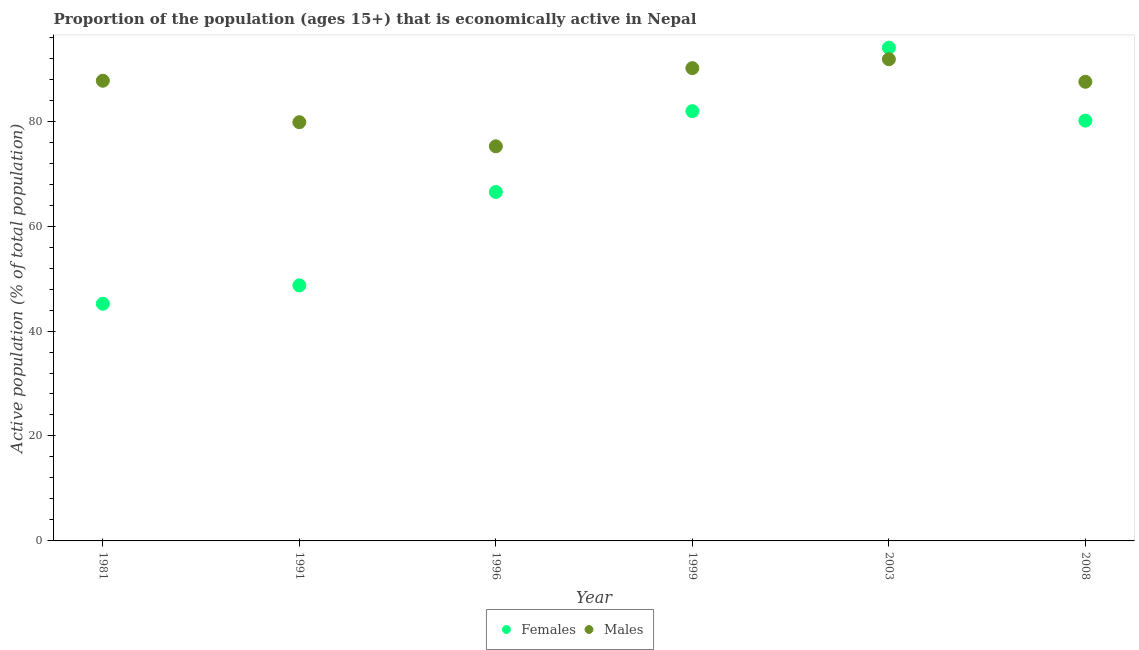Is the number of dotlines equal to the number of legend labels?
Keep it short and to the point. Yes. What is the percentage of economically active female population in 1991?
Offer a very short reply. 48.7. Across all years, what is the maximum percentage of economically active female population?
Provide a short and direct response. 94. Across all years, what is the minimum percentage of economically active male population?
Your answer should be compact. 75.2. In which year was the percentage of economically active female population maximum?
Provide a short and direct response. 2003. What is the total percentage of economically active male population in the graph?
Your answer should be compact. 512.1. What is the difference between the percentage of economically active female population in 1991 and that in 2003?
Give a very brief answer. -45.3. What is the difference between the percentage of economically active female population in 2003 and the percentage of economically active male population in 1996?
Offer a very short reply. 18.8. What is the average percentage of economically active male population per year?
Give a very brief answer. 85.35. In the year 1981, what is the difference between the percentage of economically active male population and percentage of economically active female population?
Offer a very short reply. 42.5. In how many years, is the percentage of economically active male population greater than 76 %?
Keep it short and to the point. 5. What is the ratio of the percentage of economically active male population in 1981 to that in 2003?
Provide a succinct answer. 0.96. Is the percentage of economically active male population in 1981 less than that in 2003?
Offer a terse response. Yes. Is the difference between the percentage of economically active male population in 1981 and 2003 greater than the difference between the percentage of economically active female population in 1981 and 2003?
Provide a short and direct response. Yes. What is the difference between the highest and the second highest percentage of economically active female population?
Your answer should be very brief. 12.1. What is the difference between the highest and the lowest percentage of economically active male population?
Keep it short and to the point. 16.6. In how many years, is the percentage of economically active female population greater than the average percentage of economically active female population taken over all years?
Your answer should be very brief. 3. Is the sum of the percentage of economically active male population in 1996 and 2008 greater than the maximum percentage of economically active female population across all years?
Provide a succinct answer. Yes. Does the percentage of economically active female population monotonically increase over the years?
Your answer should be very brief. No. Is the percentage of economically active male population strictly less than the percentage of economically active female population over the years?
Ensure brevity in your answer.  No. How many years are there in the graph?
Make the answer very short. 6. Where does the legend appear in the graph?
Your answer should be compact. Bottom center. How many legend labels are there?
Give a very brief answer. 2. What is the title of the graph?
Your answer should be compact. Proportion of the population (ages 15+) that is economically active in Nepal. What is the label or title of the Y-axis?
Keep it short and to the point. Active population (% of total population). What is the Active population (% of total population) in Females in 1981?
Offer a very short reply. 45.2. What is the Active population (% of total population) in Males in 1981?
Your answer should be very brief. 87.7. What is the Active population (% of total population) in Females in 1991?
Keep it short and to the point. 48.7. What is the Active population (% of total population) of Males in 1991?
Give a very brief answer. 79.8. What is the Active population (% of total population) of Females in 1996?
Offer a very short reply. 66.5. What is the Active population (% of total population) in Males in 1996?
Provide a short and direct response. 75.2. What is the Active population (% of total population) in Females in 1999?
Offer a terse response. 81.9. What is the Active population (% of total population) in Males in 1999?
Make the answer very short. 90.1. What is the Active population (% of total population) in Females in 2003?
Your answer should be compact. 94. What is the Active population (% of total population) of Males in 2003?
Provide a succinct answer. 91.8. What is the Active population (% of total population) of Females in 2008?
Ensure brevity in your answer.  80.1. What is the Active population (% of total population) of Males in 2008?
Give a very brief answer. 87.5. Across all years, what is the maximum Active population (% of total population) of Females?
Provide a short and direct response. 94. Across all years, what is the maximum Active population (% of total population) of Males?
Offer a very short reply. 91.8. Across all years, what is the minimum Active population (% of total population) in Females?
Give a very brief answer. 45.2. Across all years, what is the minimum Active population (% of total population) in Males?
Offer a terse response. 75.2. What is the total Active population (% of total population) of Females in the graph?
Your answer should be very brief. 416.4. What is the total Active population (% of total population) of Males in the graph?
Make the answer very short. 512.1. What is the difference between the Active population (% of total population) in Females in 1981 and that in 1991?
Give a very brief answer. -3.5. What is the difference between the Active population (% of total population) in Males in 1981 and that in 1991?
Your answer should be very brief. 7.9. What is the difference between the Active population (% of total population) in Females in 1981 and that in 1996?
Provide a succinct answer. -21.3. What is the difference between the Active population (% of total population) of Females in 1981 and that in 1999?
Your answer should be very brief. -36.7. What is the difference between the Active population (% of total population) of Males in 1981 and that in 1999?
Provide a short and direct response. -2.4. What is the difference between the Active population (% of total population) in Females in 1981 and that in 2003?
Offer a terse response. -48.8. What is the difference between the Active population (% of total population) in Males in 1981 and that in 2003?
Ensure brevity in your answer.  -4.1. What is the difference between the Active population (% of total population) of Females in 1981 and that in 2008?
Provide a short and direct response. -34.9. What is the difference between the Active population (% of total population) in Males in 1981 and that in 2008?
Your answer should be compact. 0.2. What is the difference between the Active population (% of total population) of Females in 1991 and that in 1996?
Your response must be concise. -17.8. What is the difference between the Active population (% of total population) in Females in 1991 and that in 1999?
Your answer should be compact. -33.2. What is the difference between the Active population (% of total population) in Females in 1991 and that in 2003?
Your answer should be compact. -45.3. What is the difference between the Active population (% of total population) in Females in 1991 and that in 2008?
Give a very brief answer. -31.4. What is the difference between the Active population (% of total population) of Females in 1996 and that in 1999?
Give a very brief answer. -15.4. What is the difference between the Active population (% of total population) in Males in 1996 and that in 1999?
Offer a terse response. -14.9. What is the difference between the Active population (% of total population) of Females in 1996 and that in 2003?
Your answer should be very brief. -27.5. What is the difference between the Active population (% of total population) of Males in 1996 and that in 2003?
Your response must be concise. -16.6. What is the difference between the Active population (% of total population) in Males in 1996 and that in 2008?
Provide a succinct answer. -12.3. What is the difference between the Active population (% of total population) of Females in 1999 and that in 2003?
Your answer should be compact. -12.1. What is the difference between the Active population (% of total population) of Females in 2003 and that in 2008?
Your answer should be compact. 13.9. What is the difference between the Active population (% of total population) of Males in 2003 and that in 2008?
Provide a succinct answer. 4.3. What is the difference between the Active population (% of total population) in Females in 1981 and the Active population (% of total population) in Males in 1991?
Ensure brevity in your answer.  -34.6. What is the difference between the Active population (% of total population) in Females in 1981 and the Active population (% of total population) in Males in 1999?
Ensure brevity in your answer.  -44.9. What is the difference between the Active population (% of total population) in Females in 1981 and the Active population (% of total population) in Males in 2003?
Provide a succinct answer. -46.6. What is the difference between the Active population (% of total population) of Females in 1981 and the Active population (% of total population) of Males in 2008?
Ensure brevity in your answer.  -42.3. What is the difference between the Active population (% of total population) in Females in 1991 and the Active population (% of total population) in Males in 1996?
Offer a very short reply. -26.5. What is the difference between the Active population (% of total population) in Females in 1991 and the Active population (% of total population) in Males in 1999?
Your response must be concise. -41.4. What is the difference between the Active population (% of total population) in Females in 1991 and the Active population (% of total population) in Males in 2003?
Provide a short and direct response. -43.1. What is the difference between the Active population (% of total population) in Females in 1991 and the Active population (% of total population) in Males in 2008?
Offer a terse response. -38.8. What is the difference between the Active population (% of total population) of Females in 1996 and the Active population (% of total population) of Males in 1999?
Provide a succinct answer. -23.6. What is the difference between the Active population (% of total population) in Females in 1996 and the Active population (% of total population) in Males in 2003?
Your answer should be very brief. -25.3. What is the difference between the Active population (% of total population) in Females in 1996 and the Active population (% of total population) in Males in 2008?
Provide a succinct answer. -21. What is the difference between the Active population (% of total population) in Females in 1999 and the Active population (% of total population) in Males in 2008?
Give a very brief answer. -5.6. What is the average Active population (% of total population) of Females per year?
Make the answer very short. 69.4. What is the average Active population (% of total population) in Males per year?
Keep it short and to the point. 85.35. In the year 1981, what is the difference between the Active population (% of total population) of Females and Active population (% of total population) of Males?
Provide a short and direct response. -42.5. In the year 1991, what is the difference between the Active population (% of total population) in Females and Active population (% of total population) in Males?
Offer a very short reply. -31.1. In the year 1996, what is the difference between the Active population (% of total population) of Females and Active population (% of total population) of Males?
Keep it short and to the point. -8.7. In the year 1999, what is the difference between the Active population (% of total population) in Females and Active population (% of total population) in Males?
Ensure brevity in your answer.  -8.2. In the year 2003, what is the difference between the Active population (% of total population) of Females and Active population (% of total population) of Males?
Provide a succinct answer. 2.2. What is the ratio of the Active population (% of total population) in Females in 1981 to that in 1991?
Your response must be concise. 0.93. What is the ratio of the Active population (% of total population) of Males in 1981 to that in 1991?
Provide a succinct answer. 1.1. What is the ratio of the Active population (% of total population) in Females in 1981 to that in 1996?
Ensure brevity in your answer.  0.68. What is the ratio of the Active population (% of total population) of Males in 1981 to that in 1996?
Offer a very short reply. 1.17. What is the ratio of the Active population (% of total population) in Females in 1981 to that in 1999?
Provide a short and direct response. 0.55. What is the ratio of the Active population (% of total population) of Males in 1981 to that in 1999?
Keep it short and to the point. 0.97. What is the ratio of the Active population (% of total population) in Females in 1981 to that in 2003?
Provide a short and direct response. 0.48. What is the ratio of the Active population (% of total population) in Males in 1981 to that in 2003?
Keep it short and to the point. 0.96. What is the ratio of the Active population (% of total population) of Females in 1981 to that in 2008?
Offer a terse response. 0.56. What is the ratio of the Active population (% of total population) in Females in 1991 to that in 1996?
Make the answer very short. 0.73. What is the ratio of the Active population (% of total population) of Males in 1991 to that in 1996?
Provide a succinct answer. 1.06. What is the ratio of the Active population (% of total population) of Females in 1991 to that in 1999?
Make the answer very short. 0.59. What is the ratio of the Active population (% of total population) in Males in 1991 to that in 1999?
Your response must be concise. 0.89. What is the ratio of the Active population (% of total population) of Females in 1991 to that in 2003?
Provide a succinct answer. 0.52. What is the ratio of the Active population (% of total population) in Males in 1991 to that in 2003?
Provide a succinct answer. 0.87. What is the ratio of the Active population (% of total population) of Females in 1991 to that in 2008?
Your response must be concise. 0.61. What is the ratio of the Active population (% of total population) in Males in 1991 to that in 2008?
Give a very brief answer. 0.91. What is the ratio of the Active population (% of total population) of Females in 1996 to that in 1999?
Offer a terse response. 0.81. What is the ratio of the Active population (% of total population) of Males in 1996 to that in 1999?
Make the answer very short. 0.83. What is the ratio of the Active population (% of total population) of Females in 1996 to that in 2003?
Provide a short and direct response. 0.71. What is the ratio of the Active population (% of total population) of Males in 1996 to that in 2003?
Your answer should be compact. 0.82. What is the ratio of the Active population (% of total population) in Females in 1996 to that in 2008?
Your answer should be very brief. 0.83. What is the ratio of the Active population (% of total population) in Males in 1996 to that in 2008?
Your answer should be compact. 0.86. What is the ratio of the Active population (% of total population) of Females in 1999 to that in 2003?
Ensure brevity in your answer.  0.87. What is the ratio of the Active population (% of total population) in Males in 1999 to that in 2003?
Provide a succinct answer. 0.98. What is the ratio of the Active population (% of total population) in Females in 1999 to that in 2008?
Ensure brevity in your answer.  1.02. What is the ratio of the Active population (% of total population) in Males in 1999 to that in 2008?
Your response must be concise. 1.03. What is the ratio of the Active population (% of total population) of Females in 2003 to that in 2008?
Offer a terse response. 1.17. What is the ratio of the Active population (% of total population) in Males in 2003 to that in 2008?
Ensure brevity in your answer.  1.05. What is the difference between the highest and the second highest Active population (% of total population) in Females?
Offer a terse response. 12.1. What is the difference between the highest and the second highest Active population (% of total population) of Males?
Your answer should be very brief. 1.7. What is the difference between the highest and the lowest Active population (% of total population) in Females?
Keep it short and to the point. 48.8. 